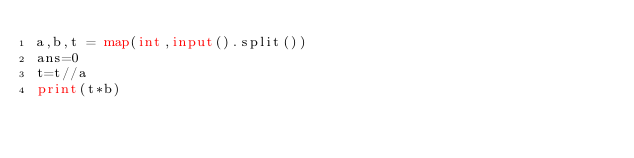<code> <loc_0><loc_0><loc_500><loc_500><_Python_>a,b,t = map(int,input().split())
ans=0
t=t//a
print(t*b)</code> 